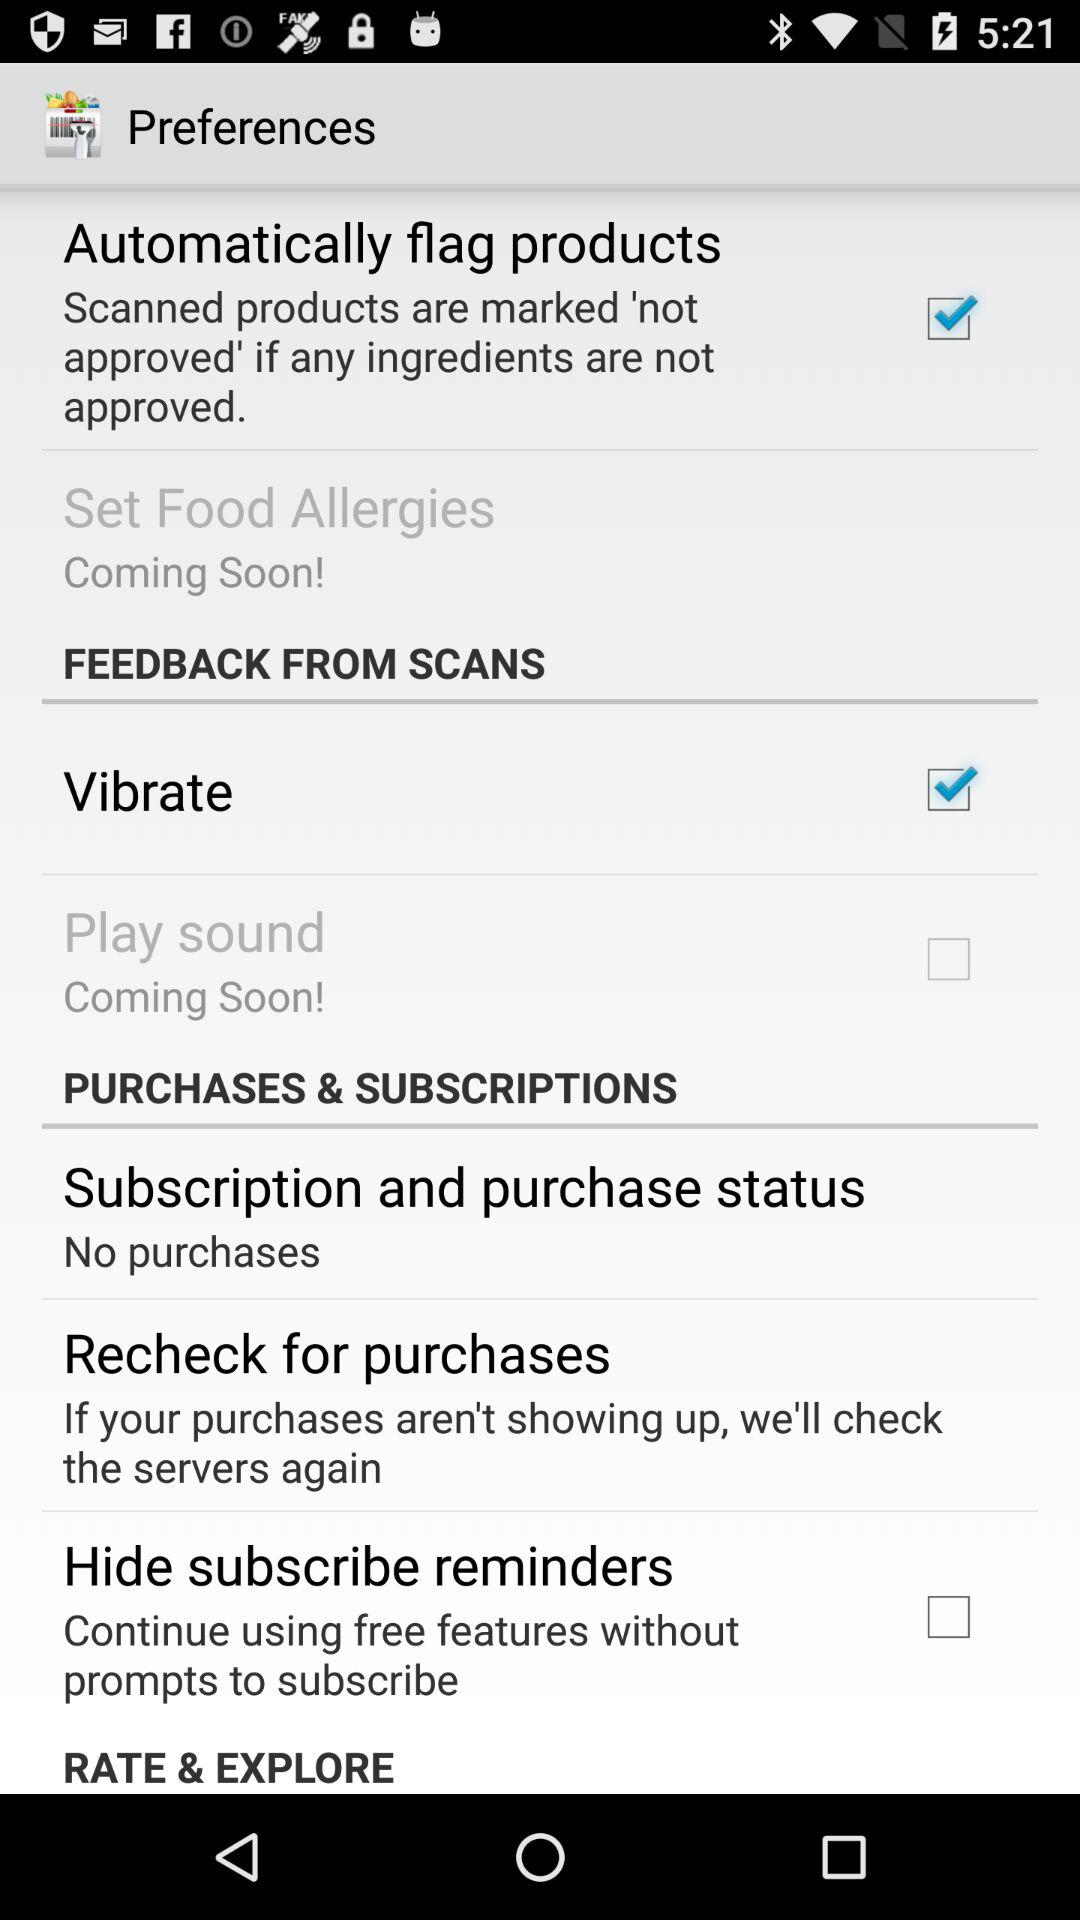What is the status of "Automatically flag products"? The status of "Automatically flag products" is "on". 